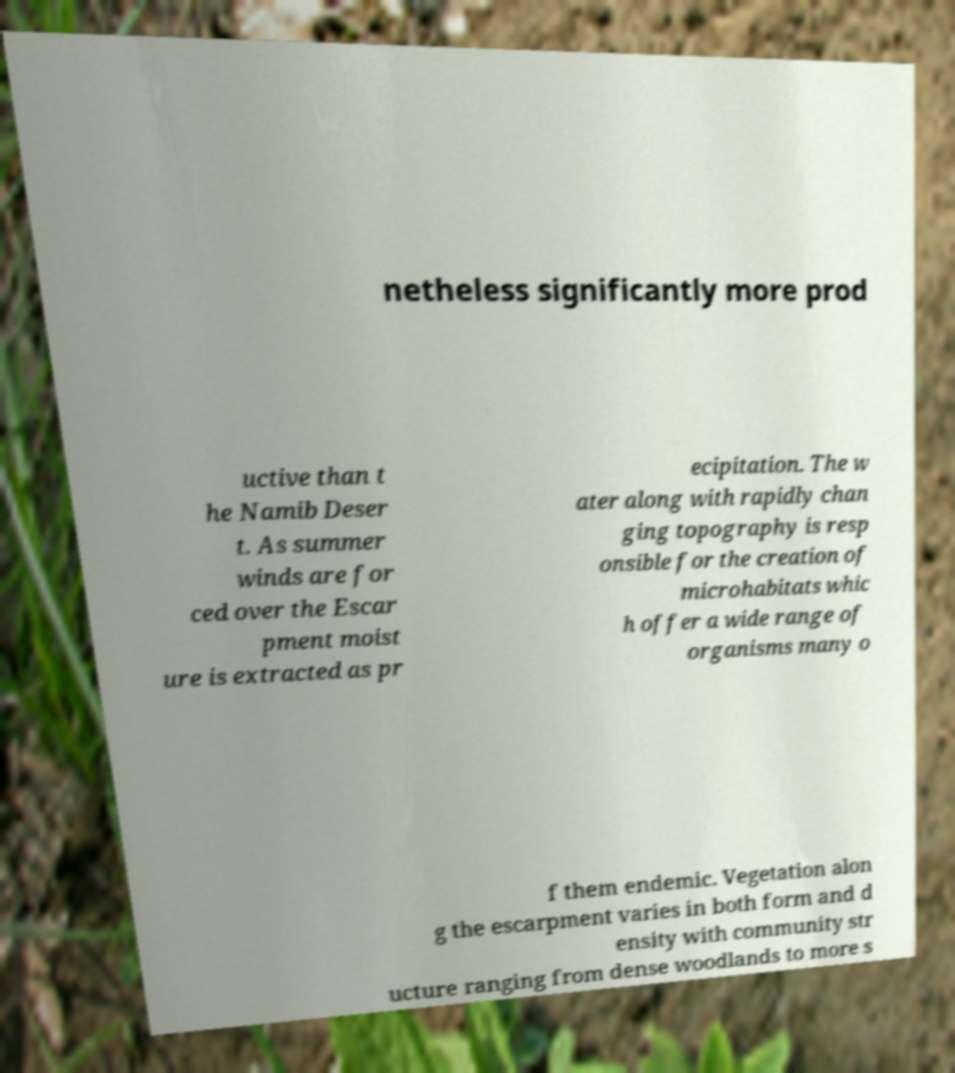Could you assist in decoding the text presented in this image and type it out clearly? netheless significantly more prod uctive than t he Namib Deser t. As summer winds are for ced over the Escar pment moist ure is extracted as pr ecipitation. The w ater along with rapidly chan ging topography is resp onsible for the creation of microhabitats whic h offer a wide range of organisms many o f them endemic. Vegetation alon g the escarpment varies in both form and d ensity with community str ucture ranging from dense woodlands to more s 